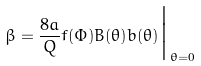Convert formula to latex. <formula><loc_0><loc_0><loc_500><loc_500>\beta = \frac { 8 a } { Q } f ( \Phi ) B ( \theta ) b ( \theta ) \Big | _ { \theta = 0 }</formula> 